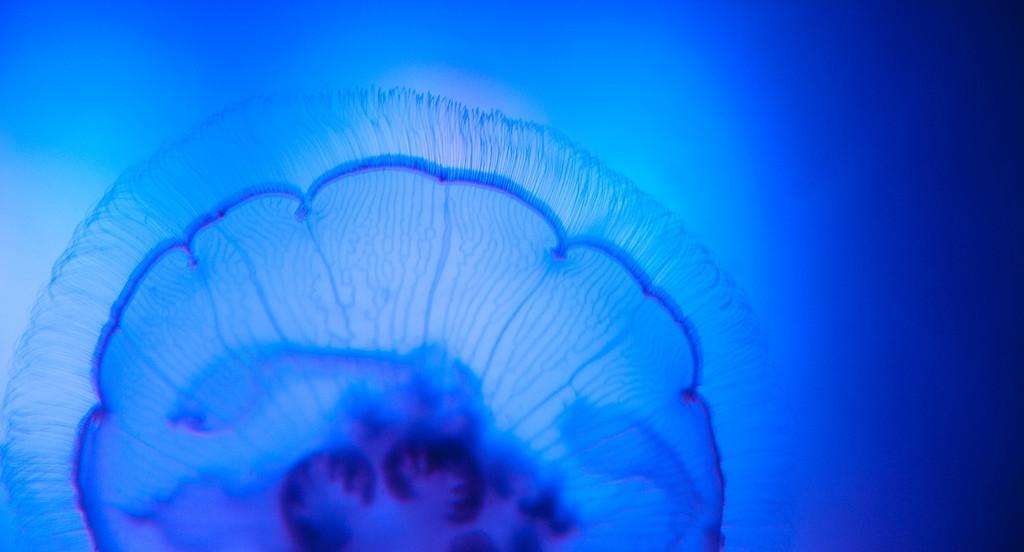Could you give a brief overview of what you see in this image? Here we can see a jellyfish in the water. 